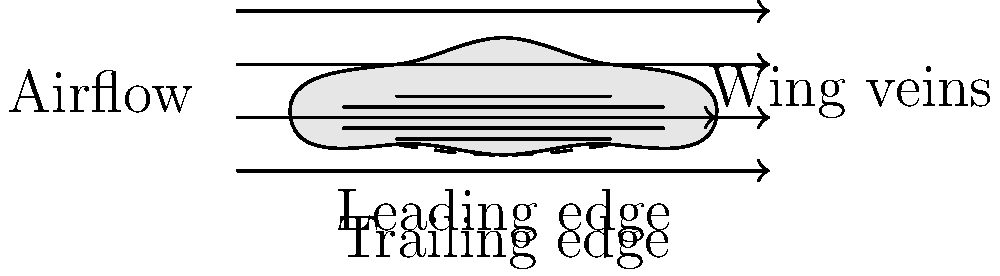In the diagram of a honeybee's wing, which structural feature is primarily responsible for creating lift during flight, and how does it contribute to the bee's ability to fly? To understand how honeybees fly, we need to examine the structure of their wings and the principles of flight mechanics:

1. Wing shape: The diagram shows an airfoil-like shape with a curved upper surface and a flatter lower surface.

2. Leading edge: This is the front part of the wing, which first encounters the airflow.

3. Trailing edge: This is the rear part of the wing, where the airflow leaves.

4. Airflow: The arrows in the diagram represent the air moving over and under the wing.

5. Bernoulli's principle: As air moves faster over the curved upper surface, it creates an area of low pressure above the wing.

6. Pressure difference: The higher pressure below the wing and lower pressure above creates lift.

7. Wing veins: These provide structural support and help maintain the wing's shape during flight.

The primary feature responsible for creating lift is the curved upper surface of the wing. This shape, combined with the flatter lower surface, creates an airfoil. When air moves over this airfoil shape, it results in a pressure difference that generates lift, allowing the bee to fly.

The wing's shape and structure are crucial for the bee's ability to fly, as they enable it to generate sufficient lift despite its small size and relatively high body mass.
Answer: The curved upper surface (airfoil shape) 